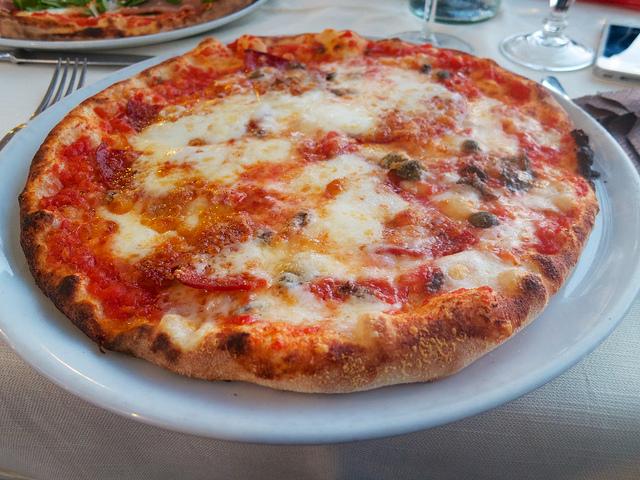Is this Mexican food?
Write a very short answer. No. What is on the plate?
Be succinct. Pizza. What utensil do you see?
Concise answer only. Fork. 